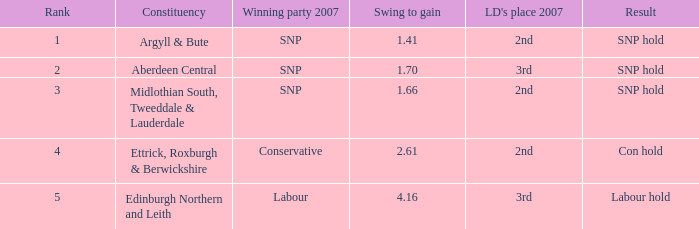What is the constituency when the swing to gain is less than 4.16, the winning party 2007 is snp and ld's place 2007 is 2nd? Argyll & Bute, Midlothian South, Tweeddale & Lauderdale. Help me parse the entirety of this table. {'header': ['Rank', 'Constituency', 'Winning party 2007', 'Swing to gain', "LD's place 2007", 'Result'], 'rows': [['1', 'Argyll & Bute', 'SNP', '1.41', '2nd', 'SNP hold'], ['2', 'Aberdeen Central', 'SNP', '1.70', '3rd', 'SNP hold'], ['3', 'Midlothian South, Tweeddale & Lauderdale', 'SNP', '1.66', '2nd', 'SNP hold'], ['4', 'Ettrick, Roxburgh & Berwickshire', 'Conservative', '2.61', '2nd', 'Con hold'], ['5', 'Edinburgh Northern and Leith', 'Labour', '4.16', '3rd', 'Labour hold']]} 